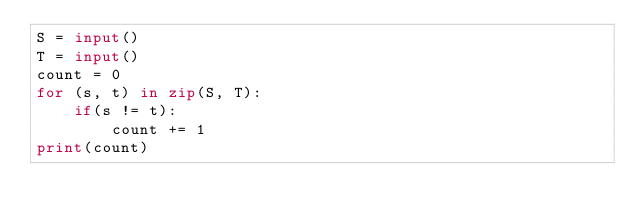Convert code to text. <code><loc_0><loc_0><loc_500><loc_500><_Python_>S = input()
T = input()
count = 0
for (s, t) in zip(S, T):
    if(s != t):
        count += 1
print(count)</code> 